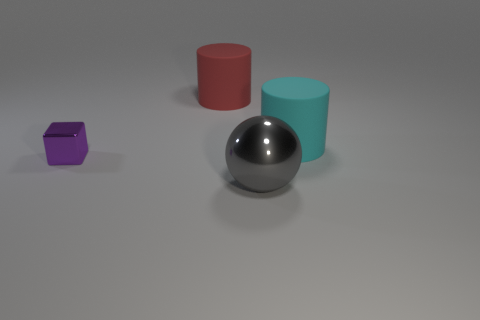Subtract all red cylinders. Subtract all green spheres. How many cylinders are left? 1 Add 2 purple objects. How many objects exist? 6 Subtract all cubes. How many objects are left? 3 Add 2 big green blocks. How many big green blocks exist? 2 Subtract 1 gray spheres. How many objects are left? 3 Subtract all large red matte things. Subtract all red matte cubes. How many objects are left? 3 Add 4 cyan objects. How many cyan objects are left? 5 